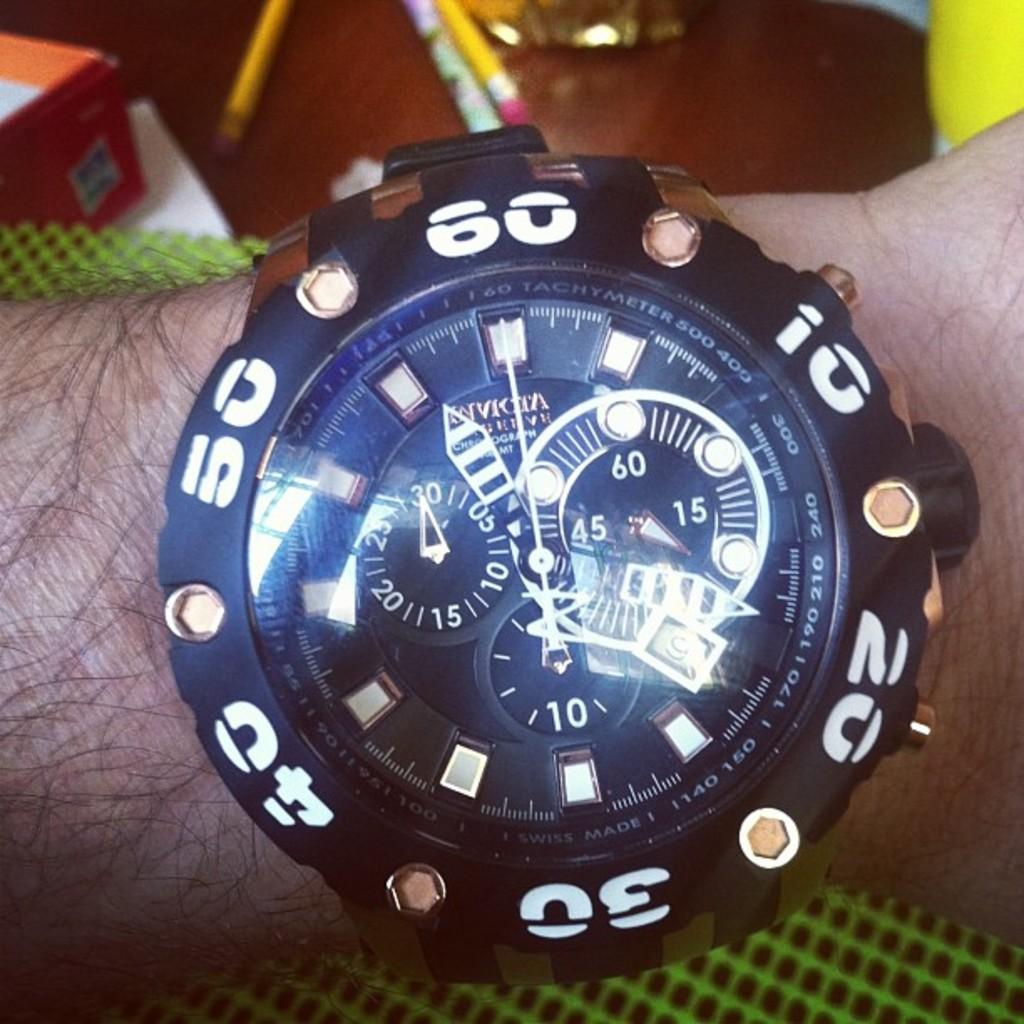<image>
Present a compact description of the photo's key features. A black watch with white numbers currently has the minute hand aiming towards the "60" 